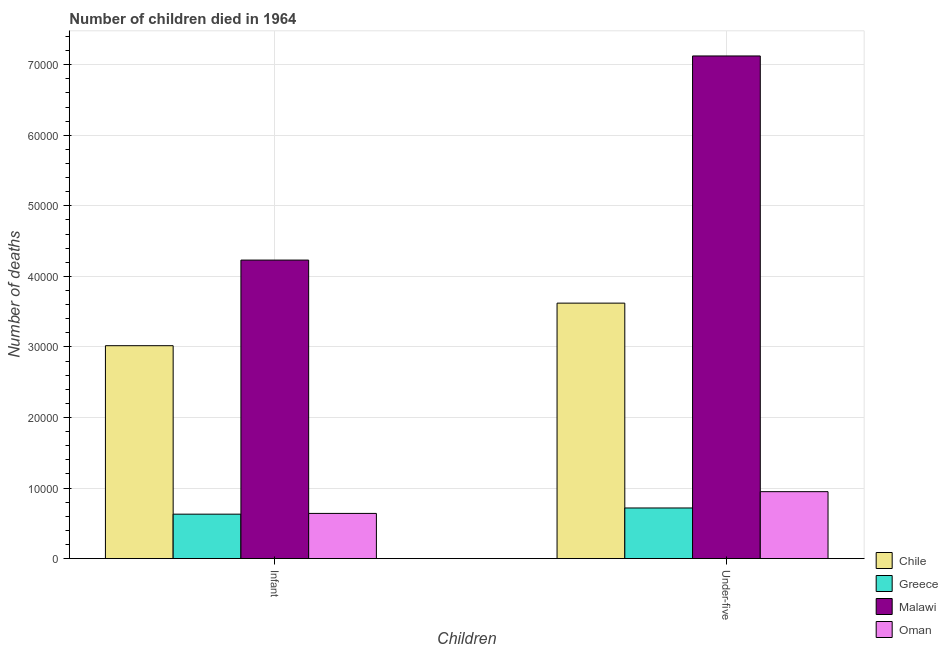How many groups of bars are there?
Make the answer very short. 2. Are the number of bars per tick equal to the number of legend labels?
Keep it short and to the point. Yes. How many bars are there on the 1st tick from the left?
Give a very brief answer. 4. How many bars are there on the 1st tick from the right?
Your answer should be compact. 4. What is the label of the 1st group of bars from the left?
Keep it short and to the point. Infant. What is the number of infant deaths in Oman?
Make the answer very short. 6400. Across all countries, what is the maximum number of under-five deaths?
Keep it short and to the point. 7.12e+04. Across all countries, what is the minimum number of under-five deaths?
Your answer should be compact. 7172. In which country was the number of under-five deaths maximum?
Your response must be concise. Malawi. In which country was the number of infant deaths minimum?
Your response must be concise. Greece. What is the total number of under-five deaths in the graph?
Offer a very short reply. 1.24e+05. What is the difference between the number of infant deaths in Malawi and that in Chile?
Provide a succinct answer. 1.21e+04. What is the difference between the number of under-five deaths in Oman and the number of infant deaths in Chile?
Your answer should be compact. -2.07e+04. What is the average number of infant deaths per country?
Make the answer very short. 2.13e+04. What is the difference between the number of under-five deaths and number of infant deaths in Greece?
Make the answer very short. 878. What is the ratio of the number of under-five deaths in Oman to that in Greece?
Offer a terse response. 1.32. What does the 1st bar from the right in Infant represents?
Make the answer very short. Oman. How many bars are there?
Keep it short and to the point. 8. Are the values on the major ticks of Y-axis written in scientific E-notation?
Your answer should be compact. No. Does the graph contain any zero values?
Your answer should be compact. No. Does the graph contain grids?
Make the answer very short. Yes. Where does the legend appear in the graph?
Your answer should be very brief. Bottom right. How many legend labels are there?
Ensure brevity in your answer.  4. How are the legend labels stacked?
Your response must be concise. Vertical. What is the title of the graph?
Your answer should be compact. Number of children died in 1964. What is the label or title of the X-axis?
Your answer should be compact. Children. What is the label or title of the Y-axis?
Offer a very short reply. Number of deaths. What is the Number of deaths of Chile in Infant?
Your answer should be very brief. 3.02e+04. What is the Number of deaths of Greece in Infant?
Provide a short and direct response. 6294. What is the Number of deaths of Malawi in Infant?
Make the answer very short. 4.23e+04. What is the Number of deaths in Oman in Infant?
Your response must be concise. 6400. What is the Number of deaths in Chile in Under-five?
Your answer should be compact. 3.62e+04. What is the Number of deaths in Greece in Under-five?
Make the answer very short. 7172. What is the Number of deaths of Malawi in Under-five?
Your response must be concise. 7.12e+04. What is the Number of deaths of Oman in Under-five?
Keep it short and to the point. 9483. Across all Children, what is the maximum Number of deaths of Chile?
Offer a terse response. 3.62e+04. Across all Children, what is the maximum Number of deaths in Greece?
Make the answer very short. 7172. Across all Children, what is the maximum Number of deaths in Malawi?
Your answer should be very brief. 7.12e+04. Across all Children, what is the maximum Number of deaths in Oman?
Make the answer very short. 9483. Across all Children, what is the minimum Number of deaths in Chile?
Your answer should be very brief. 3.02e+04. Across all Children, what is the minimum Number of deaths in Greece?
Provide a short and direct response. 6294. Across all Children, what is the minimum Number of deaths of Malawi?
Your response must be concise. 4.23e+04. Across all Children, what is the minimum Number of deaths of Oman?
Your answer should be very brief. 6400. What is the total Number of deaths in Chile in the graph?
Offer a very short reply. 6.64e+04. What is the total Number of deaths in Greece in the graph?
Offer a terse response. 1.35e+04. What is the total Number of deaths in Malawi in the graph?
Offer a very short reply. 1.14e+05. What is the total Number of deaths of Oman in the graph?
Give a very brief answer. 1.59e+04. What is the difference between the Number of deaths of Chile in Infant and that in Under-five?
Your answer should be compact. -6032. What is the difference between the Number of deaths in Greece in Infant and that in Under-five?
Provide a succinct answer. -878. What is the difference between the Number of deaths in Malawi in Infant and that in Under-five?
Provide a short and direct response. -2.89e+04. What is the difference between the Number of deaths of Oman in Infant and that in Under-five?
Make the answer very short. -3083. What is the difference between the Number of deaths in Chile in Infant and the Number of deaths in Greece in Under-five?
Your answer should be compact. 2.30e+04. What is the difference between the Number of deaths of Chile in Infant and the Number of deaths of Malawi in Under-five?
Make the answer very short. -4.11e+04. What is the difference between the Number of deaths of Chile in Infant and the Number of deaths of Oman in Under-five?
Your response must be concise. 2.07e+04. What is the difference between the Number of deaths of Greece in Infant and the Number of deaths of Malawi in Under-five?
Provide a succinct answer. -6.50e+04. What is the difference between the Number of deaths of Greece in Infant and the Number of deaths of Oman in Under-five?
Make the answer very short. -3189. What is the difference between the Number of deaths of Malawi in Infant and the Number of deaths of Oman in Under-five?
Provide a succinct answer. 3.28e+04. What is the average Number of deaths in Chile per Children?
Ensure brevity in your answer.  3.32e+04. What is the average Number of deaths of Greece per Children?
Offer a terse response. 6733. What is the average Number of deaths of Malawi per Children?
Your answer should be compact. 5.68e+04. What is the average Number of deaths of Oman per Children?
Your response must be concise. 7941.5. What is the difference between the Number of deaths in Chile and Number of deaths in Greece in Infant?
Keep it short and to the point. 2.39e+04. What is the difference between the Number of deaths of Chile and Number of deaths of Malawi in Infant?
Offer a terse response. -1.21e+04. What is the difference between the Number of deaths in Chile and Number of deaths in Oman in Infant?
Provide a short and direct response. 2.38e+04. What is the difference between the Number of deaths of Greece and Number of deaths of Malawi in Infant?
Make the answer very short. -3.60e+04. What is the difference between the Number of deaths of Greece and Number of deaths of Oman in Infant?
Offer a terse response. -106. What is the difference between the Number of deaths of Malawi and Number of deaths of Oman in Infant?
Provide a short and direct response. 3.59e+04. What is the difference between the Number of deaths in Chile and Number of deaths in Greece in Under-five?
Ensure brevity in your answer.  2.90e+04. What is the difference between the Number of deaths of Chile and Number of deaths of Malawi in Under-five?
Make the answer very short. -3.50e+04. What is the difference between the Number of deaths in Chile and Number of deaths in Oman in Under-five?
Your answer should be very brief. 2.67e+04. What is the difference between the Number of deaths of Greece and Number of deaths of Malawi in Under-five?
Give a very brief answer. -6.41e+04. What is the difference between the Number of deaths of Greece and Number of deaths of Oman in Under-five?
Offer a terse response. -2311. What is the difference between the Number of deaths of Malawi and Number of deaths of Oman in Under-five?
Keep it short and to the point. 6.18e+04. What is the ratio of the Number of deaths of Chile in Infant to that in Under-five?
Offer a terse response. 0.83. What is the ratio of the Number of deaths of Greece in Infant to that in Under-five?
Your response must be concise. 0.88. What is the ratio of the Number of deaths of Malawi in Infant to that in Under-five?
Make the answer very short. 0.59. What is the ratio of the Number of deaths in Oman in Infant to that in Under-five?
Provide a short and direct response. 0.67. What is the difference between the highest and the second highest Number of deaths in Chile?
Offer a terse response. 6032. What is the difference between the highest and the second highest Number of deaths in Greece?
Give a very brief answer. 878. What is the difference between the highest and the second highest Number of deaths in Malawi?
Your answer should be compact. 2.89e+04. What is the difference between the highest and the second highest Number of deaths of Oman?
Make the answer very short. 3083. What is the difference between the highest and the lowest Number of deaths in Chile?
Keep it short and to the point. 6032. What is the difference between the highest and the lowest Number of deaths of Greece?
Offer a terse response. 878. What is the difference between the highest and the lowest Number of deaths of Malawi?
Offer a terse response. 2.89e+04. What is the difference between the highest and the lowest Number of deaths of Oman?
Offer a terse response. 3083. 